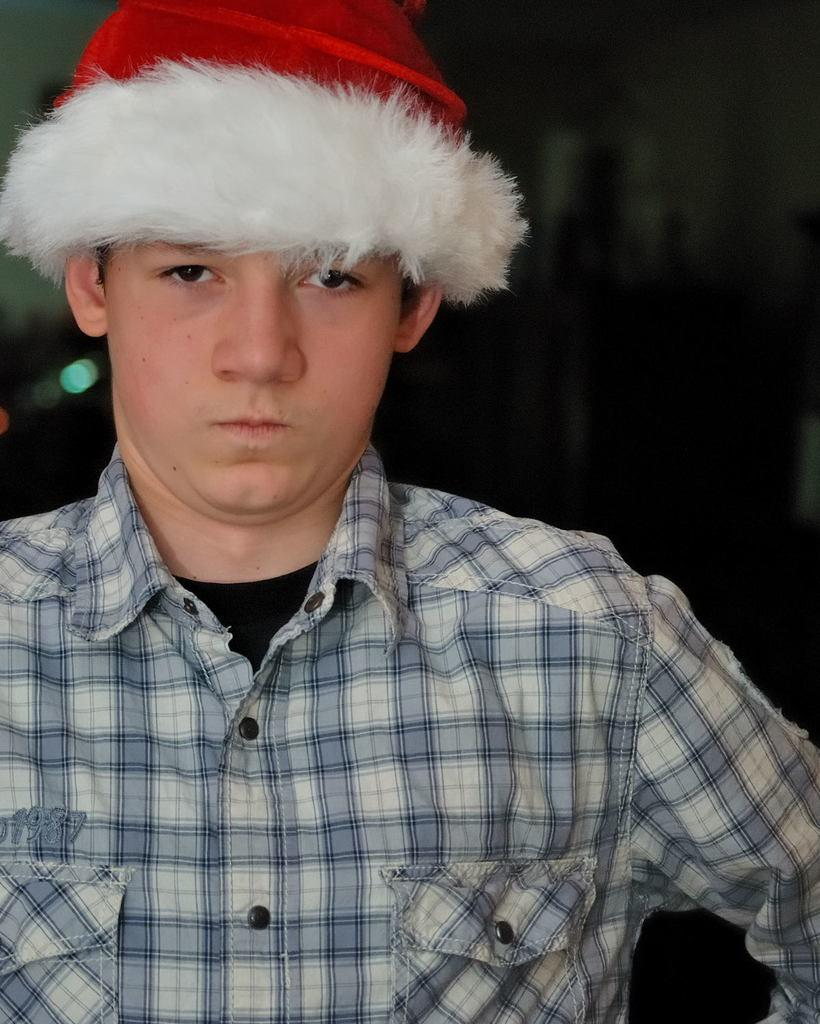Who is the main subject in the image? There is a boy in the image. What is the boy wearing? The boy is wearing clothes and a Santa cap. What can be observed about the background of the image? The background of the image is dark. What is the boy's net worth in the image? There is no information about the boy's net worth in the image. What historical event is depicted in the image? There is no historical event depicted in the image; it features a boy wearing a Santa cap. 